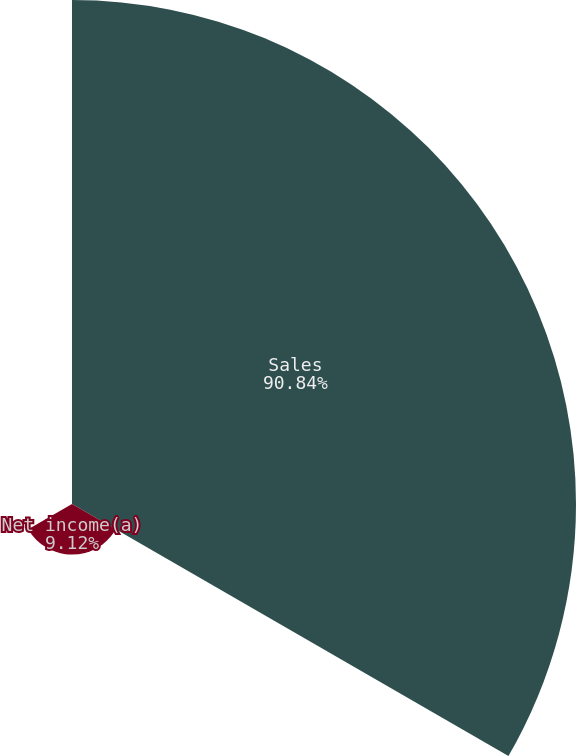<chart> <loc_0><loc_0><loc_500><loc_500><pie_chart><fcel>Sales<fcel>Net income(a)<fcel>Net income per share - diluted<nl><fcel>90.84%<fcel>9.12%<fcel>0.04%<nl></chart> 